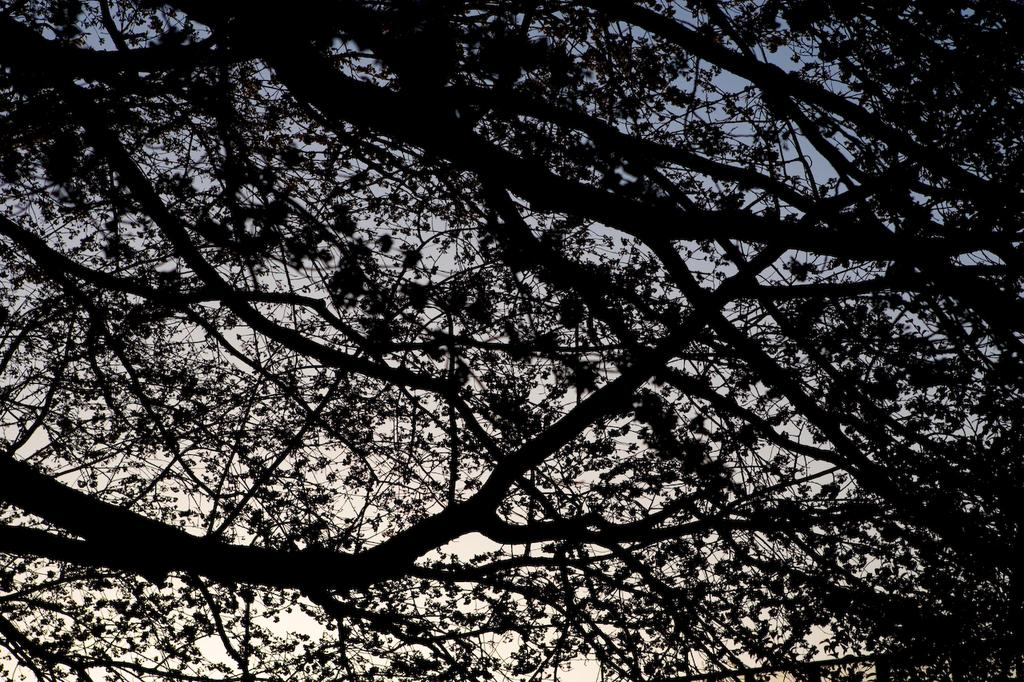What type of vegetation can be seen in the image? Tree branches are visible in the image. What is the condition of the sky in the image? The sky appears to be cloudy in the image. What type of holiday is being celebrated in the image? There is no indication of a holiday being celebrated in the image. Where is the harbor located in the image? There is no harbor present in the image. 